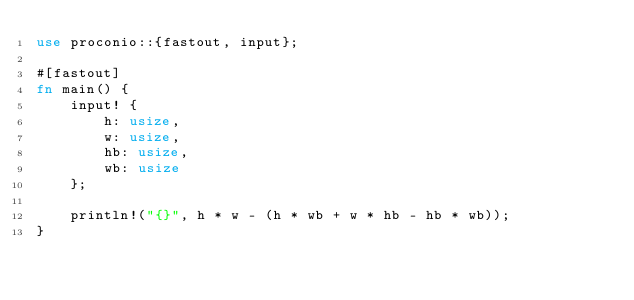<code> <loc_0><loc_0><loc_500><loc_500><_Rust_>use proconio::{fastout, input};

#[fastout]
fn main() {
    input! {
        h: usize,
        w: usize,
        hb: usize,
        wb: usize
    };

    println!("{}", h * w - (h * wb + w * hb - hb * wb));
}
</code> 